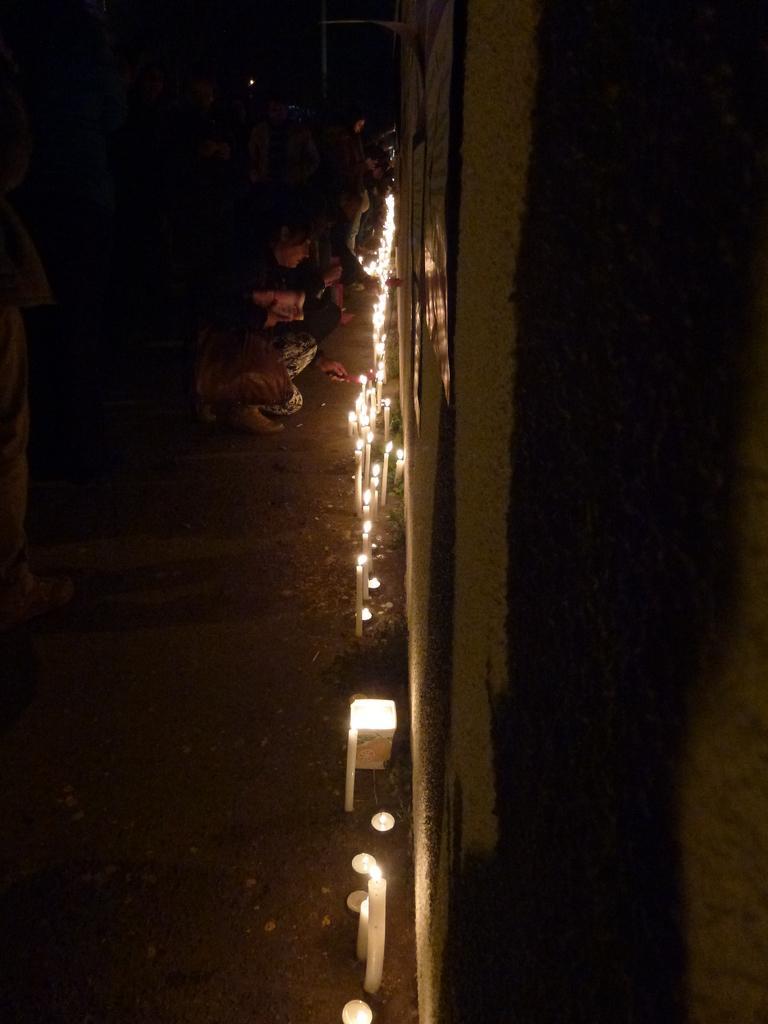How would you summarize this image in a sentence or two? In this image we can see some people, candles and other objects. At the bottom of the image there is the ground. On the right side of the image it looks like a wall. 